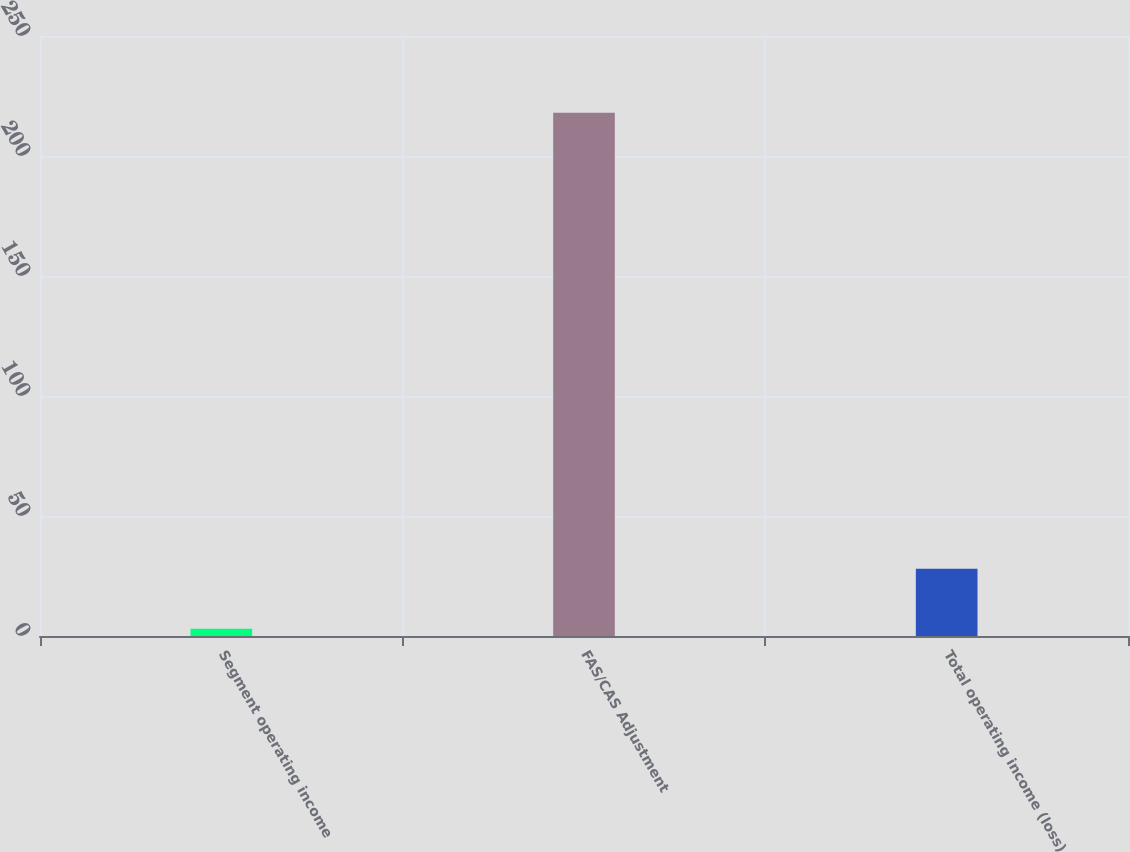Convert chart to OTSL. <chart><loc_0><loc_0><loc_500><loc_500><bar_chart><fcel>Segment operating income<fcel>FAS/CAS Adjustment<fcel>Total operating income (loss)<nl><fcel>3<fcel>218<fcel>28<nl></chart> 